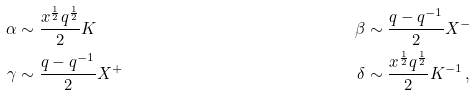Convert formula to latex. <formula><loc_0><loc_0><loc_500><loc_500>\alpha & \sim \frac { x ^ { \frac { 1 } { 2 } } q ^ { \frac { 1 } { 2 } } } { 2 } K & \beta & \sim \frac { q - q ^ { - 1 } } { 2 } X ^ { - } \\ \gamma & \sim \frac { q - q ^ { - 1 } } { 2 } X ^ { + } & \delta & \sim \frac { x ^ { \frac { 1 } { 2 } } q ^ { \frac { 1 } { 2 } } } { 2 } K ^ { - 1 } \, ,</formula> 